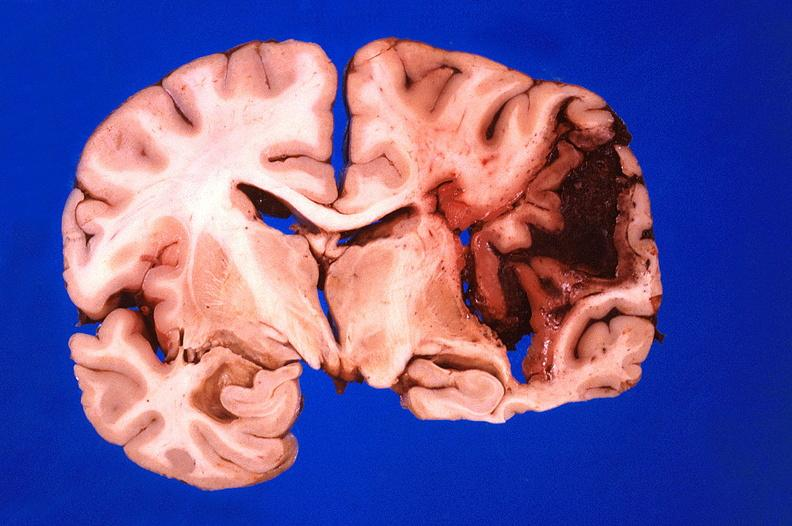what is present?
Answer the question using a single word or phrase. Nervous 